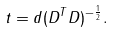Convert formula to latex. <formula><loc_0><loc_0><loc_500><loc_500>t = d ( D ^ { T } D ) ^ { - { \frac { 1 } { 2 } } } .</formula> 